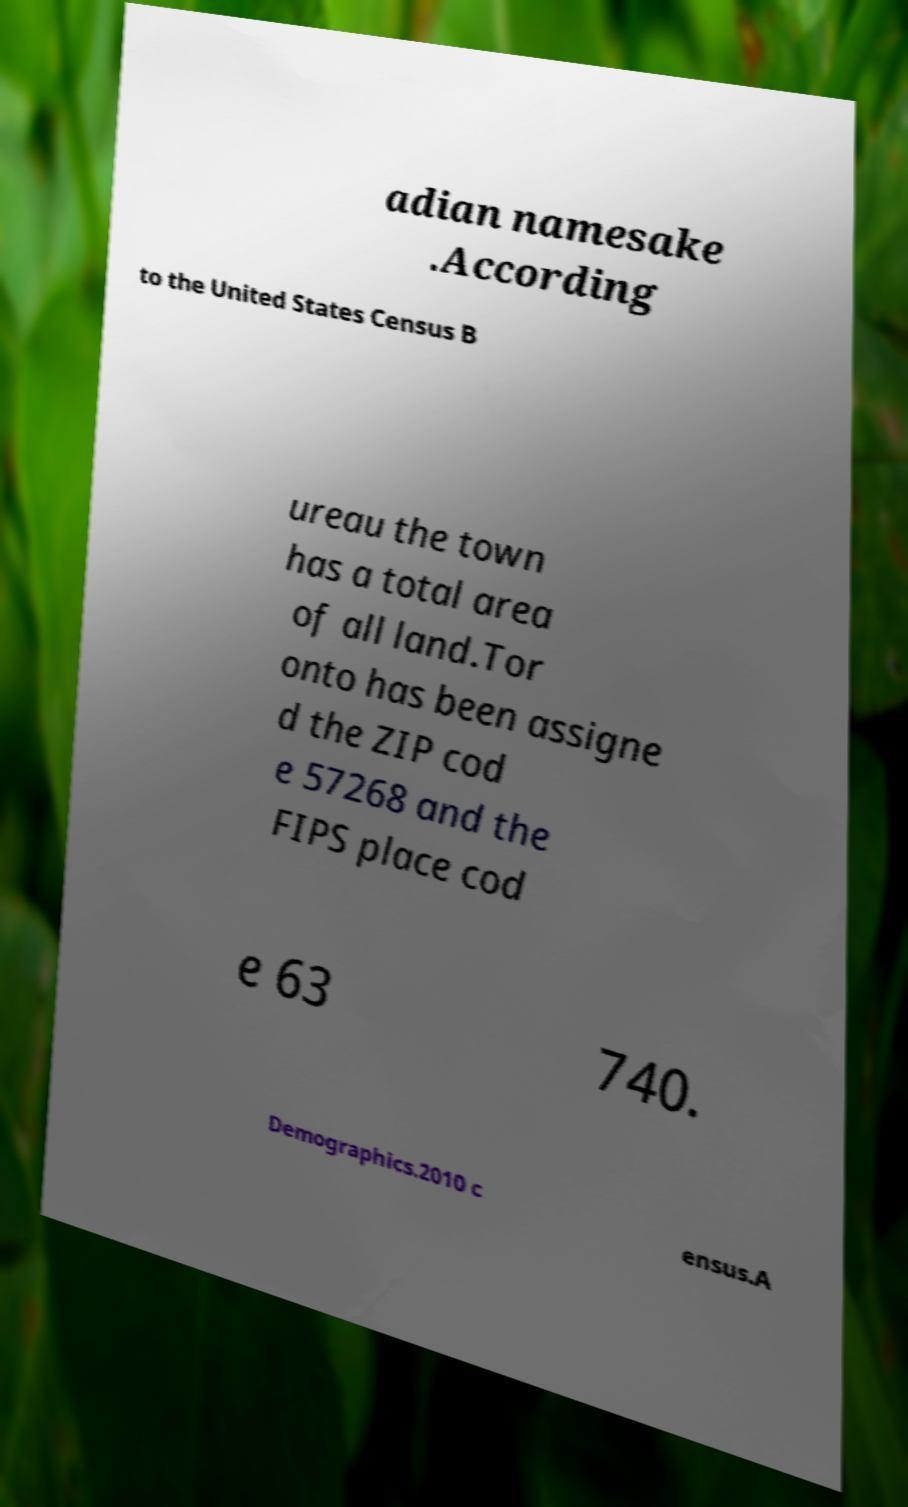For documentation purposes, I need the text within this image transcribed. Could you provide that? adian namesake .According to the United States Census B ureau the town has a total area of all land.Tor onto has been assigne d the ZIP cod e 57268 and the FIPS place cod e 63 740. Demographics.2010 c ensus.A 